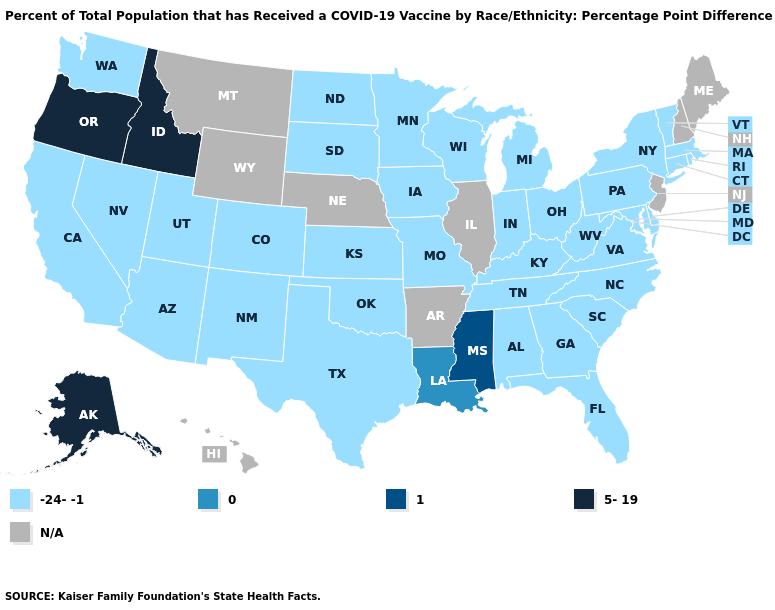What is the lowest value in the South?
Be succinct. -24--1. Which states have the lowest value in the South?
Quick response, please. Alabama, Delaware, Florida, Georgia, Kentucky, Maryland, North Carolina, Oklahoma, South Carolina, Tennessee, Texas, Virginia, West Virginia. Among the states that border Arkansas , does Mississippi have the highest value?
Give a very brief answer. Yes. How many symbols are there in the legend?
Quick response, please. 5. Is the legend a continuous bar?
Short answer required. No. What is the value of Maryland?
Concise answer only. -24--1. What is the lowest value in the MidWest?
Be succinct. -24--1. Name the states that have a value in the range 5-19?
Keep it brief. Alaska, Idaho, Oregon. Does Louisiana have the lowest value in the USA?
Keep it brief. No. Name the states that have a value in the range -24--1?
Concise answer only. Alabama, Arizona, California, Colorado, Connecticut, Delaware, Florida, Georgia, Indiana, Iowa, Kansas, Kentucky, Maryland, Massachusetts, Michigan, Minnesota, Missouri, Nevada, New Mexico, New York, North Carolina, North Dakota, Ohio, Oklahoma, Pennsylvania, Rhode Island, South Carolina, South Dakota, Tennessee, Texas, Utah, Vermont, Virginia, Washington, West Virginia, Wisconsin. What is the value of Kansas?
Give a very brief answer. -24--1. What is the lowest value in states that border Indiana?
Concise answer only. -24--1. 